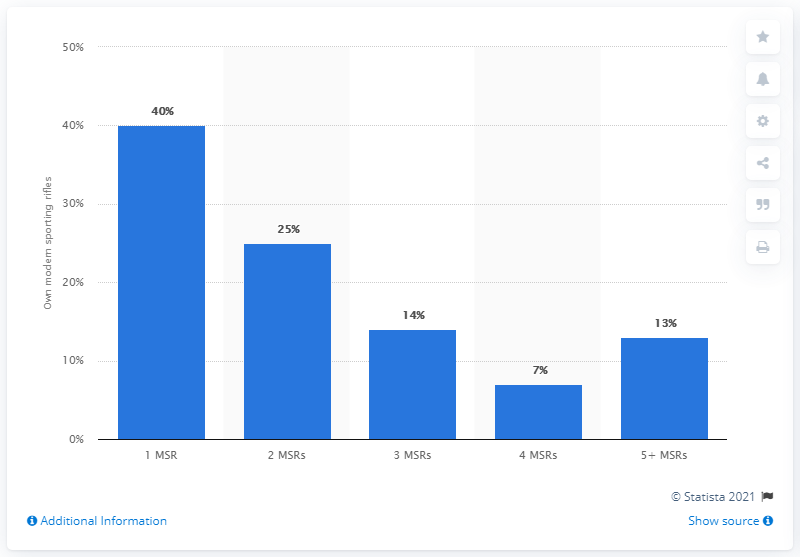Indicate a few pertinent items in this graphic. According to the data, 40% of owners have only one Moderately Sized Retail Business (MSR). 